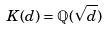<formula> <loc_0><loc_0><loc_500><loc_500>K ( d ) = \mathbb { Q } ( \sqrt { d } )</formula> 